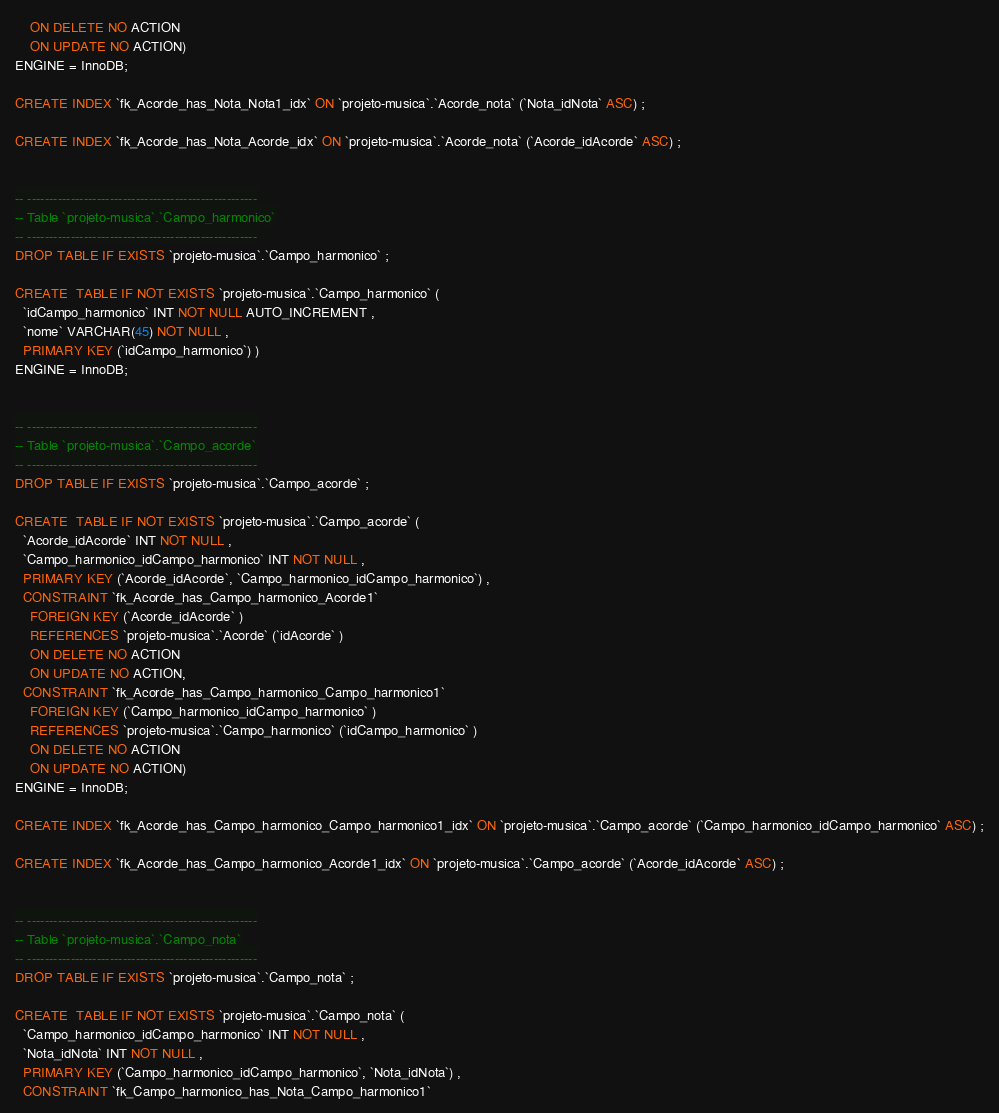Convert code to text. <code><loc_0><loc_0><loc_500><loc_500><_SQL_>    ON DELETE NO ACTION
    ON UPDATE NO ACTION)
ENGINE = InnoDB;

CREATE INDEX `fk_Acorde_has_Nota_Nota1_idx` ON `projeto-musica`.`Acorde_nota` (`Nota_idNota` ASC) ;

CREATE INDEX `fk_Acorde_has_Nota_Acorde_idx` ON `projeto-musica`.`Acorde_nota` (`Acorde_idAcorde` ASC) ;


-- -----------------------------------------------------
-- Table `projeto-musica`.`Campo_harmonico`
-- -----------------------------------------------------
DROP TABLE IF EXISTS `projeto-musica`.`Campo_harmonico` ;

CREATE  TABLE IF NOT EXISTS `projeto-musica`.`Campo_harmonico` (
  `idCampo_harmonico` INT NOT NULL AUTO_INCREMENT ,
  `nome` VARCHAR(45) NOT NULL ,
  PRIMARY KEY (`idCampo_harmonico`) )
ENGINE = InnoDB;


-- -----------------------------------------------------
-- Table `projeto-musica`.`Campo_acorde`
-- -----------------------------------------------------
DROP TABLE IF EXISTS `projeto-musica`.`Campo_acorde` ;

CREATE  TABLE IF NOT EXISTS `projeto-musica`.`Campo_acorde` (
  `Acorde_idAcorde` INT NOT NULL ,
  `Campo_harmonico_idCampo_harmonico` INT NOT NULL ,
  PRIMARY KEY (`Acorde_idAcorde`, `Campo_harmonico_idCampo_harmonico`) ,
  CONSTRAINT `fk_Acorde_has_Campo_harmonico_Acorde1`
    FOREIGN KEY (`Acorde_idAcorde` )
    REFERENCES `projeto-musica`.`Acorde` (`idAcorde` )
    ON DELETE NO ACTION
    ON UPDATE NO ACTION,
  CONSTRAINT `fk_Acorde_has_Campo_harmonico_Campo_harmonico1`
    FOREIGN KEY (`Campo_harmonico_idCampo_harmonico` )
    REFERENCES `projeto-musica`.`Campo_harmonico` (`idCampo_harmonico` )
    ON DELETE NO ACTION
    ON UPDATE NO ACTION)
ENGINE = InnoDB;

CREATE INDEX `fk_Acorde_has_Campo_harmonico_Campo_harmonico1_idx` ON `projeto-musica`.`Campo_acorde` (`Campo_harmonico_idCampo_harmonico` ASC) ;

CREATE INDEX `fk_Acorde_has_Campo_harmonico_Acorde1_idx` ON `projeto-musica`.`Campo_acorde` (`Acorde_idAcorde` ASC) ;


-- -----------------------------------------------------
-- Table `projeto-musica`.`Campo_nota`
-- -----------------------------------------------------
DROP TABLE IF EXISTS `projeto-musica`.`Campo_nota` ;

CREATE  TABLE IF NOT EXISTS `projeto-musica`.`Campo_nota` (
  `Campo_harmonico_idCampo_harmonico` INT NOT NULL ,
  `Nota_idNota` INT NOT NULL ,
  PRIMARY KEY (`Campo_harmonico_idCampo_harmonico`, `Nota_idNota`) ,
  CONSTRAINT `fk_Campo_harmonico_has_Nota_Campo_harmonico1`</code> 